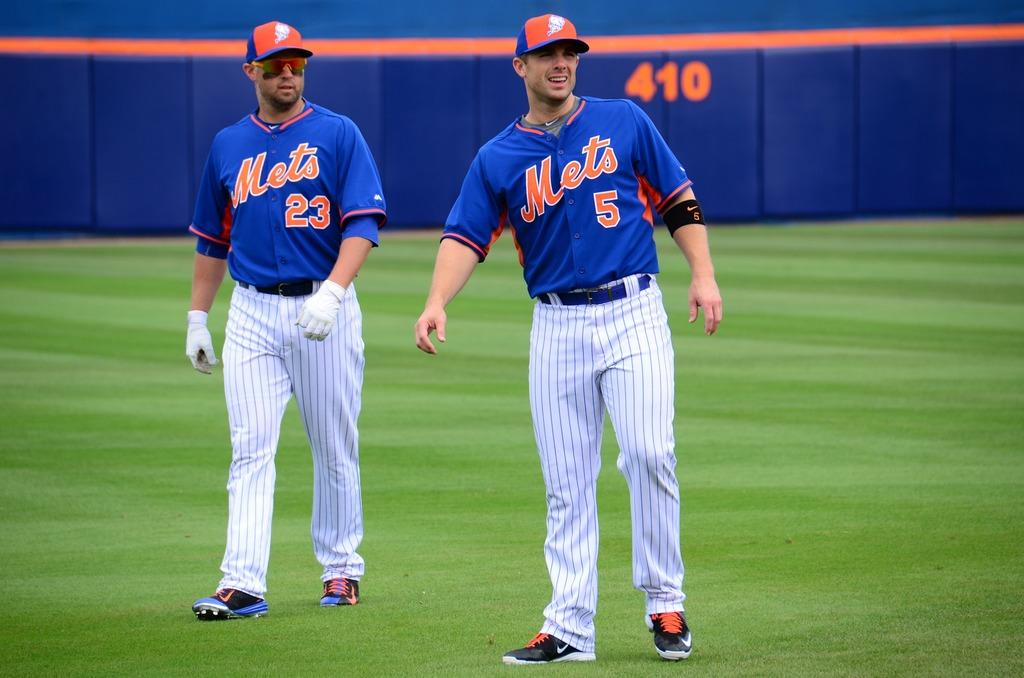<image>
Present a compact description of the photo's key features. Two Mets baseball players wearing numbers 23 and 5 are walking on a baseball field. 